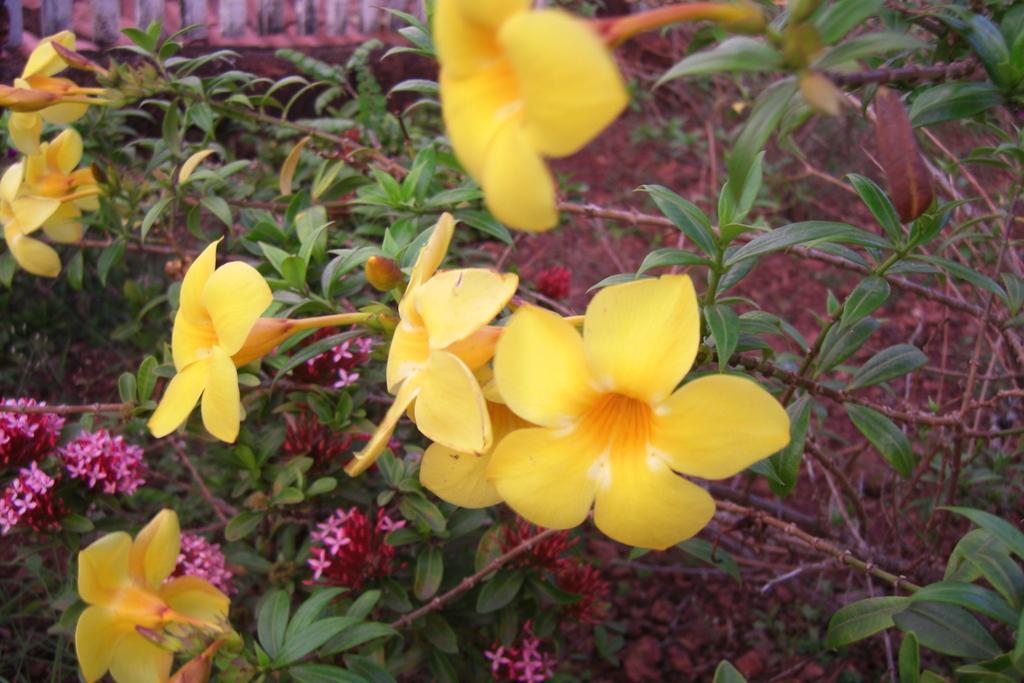Please provide a concise description of this image. In the image we can see there are flowers, yellow, pink and red in colors. Here we can see the leaves and stem of the flower. 